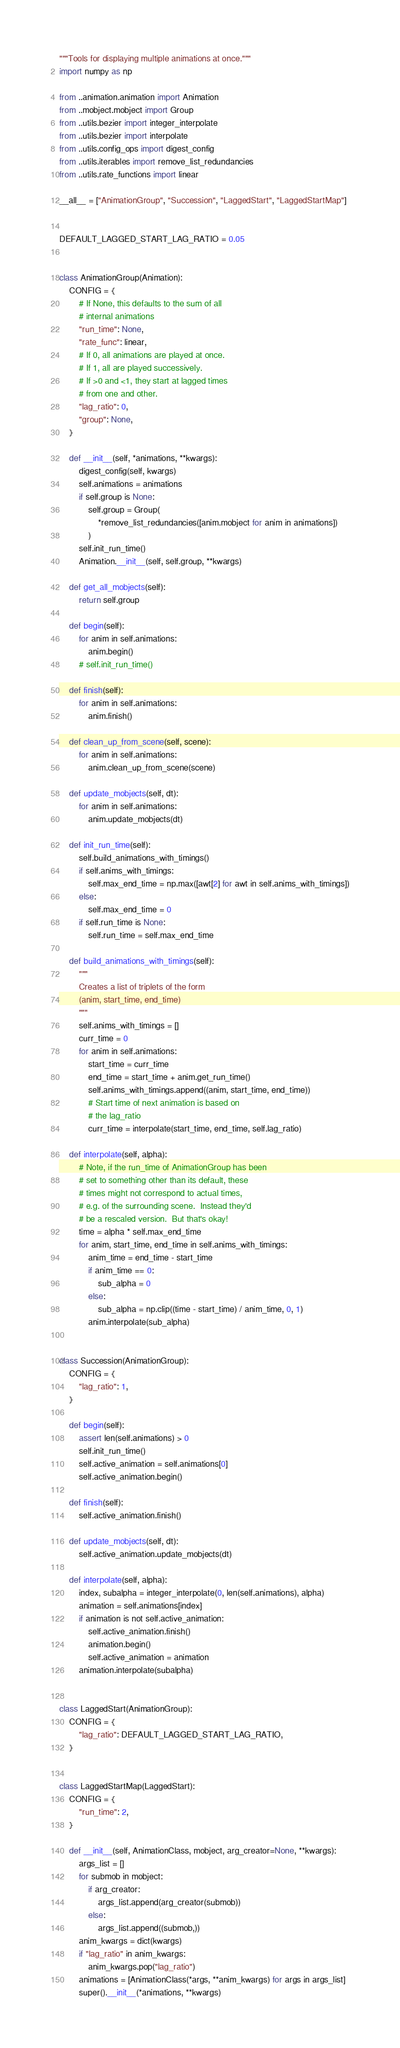Convert code to text. <code><loc_0><loc_0><loc_500><loc_500><_Python_>"""Tools for displaying multiple animations at once."""
import numpy as np

from ..animation.animation import Animation
from ..mobject.mobject import Group
from ..utils.bezier import integer_interpolate
from ..utils.bezier import interpolate
from ..utils.config_ops import digest_config
from ..utils.iterables import remove_list_redundancies
from ..utils.rate_functions import linear

__all__ = ["AnimationGroup", "Succession", "LaggedStart", "LaggedStartMap"]


DEFAULT_LAGGED_START_LAG_RATIO = 0.05


class AnimationGroup(Animation):
    CONFIG = {
        # If None, this defaults to the sum of all
        # internal animations
        "run_time": None,
        "rate_func": linear,
        # If 0, all animations are played at once.
        # If 1, all are played successively.
        # If >0 and <1, they start at lagged times
        # from one and other.
        "lag_ratio": 0,
        "group": None,
    }

    def __init__(self, *animations, **kwargs):
        digest_config(self, kwargs)
        self.animations = animations
        if self.group is None:
            self.group = Group(
                *remove_list_redundancies([anim.mobject for anim in animations])
            )
        self.init_run_time()
        Animation.__init__(self, self.group, **kwargs)

    def get_all_mobjects(self):
        return self.group

    def begin(self):
        for anim in self.animations:
            anim.begin()
        # self.init_run_time()

    def finish(self):
        for anim in self.animations:
            anim.finish()

    def clean_up_from_scene(self, scene):
        for anim in self.animations:
            anim.clean_up_from_scene(scene)

    def update_mobjects(self, dt):
        for anim in self.animations:
            anim.update_mobjects(dt)

    def init_run_time(self):
        self.build_animations_with_timings()
        if self.anims_with_timings:
            self.max_end_time = np.max([awt[2] for awt in self.anims_with_timings])
        else:
            self.max_end_time = 0
        if self.run_time is None:
            self.run_time = self.max_end_time

    def build_animations_with_timings(self):
        """
        Creates a list of triplets of the form
        (anim, start_time, end_time)
        """
        self.anims_with_timings = []
        curr_time = 0
        for anim in self.animations:
            start_time = curr_time
            end_time = start_time + anim.get_run_time()
            self.anims_with_timings.append((anim, start_time, end_time))
            # Start time of next animation is based on
            # the lag_ratio
            curr_time = interpolate(start_time, end_time, self.lag_ratio)

    def interpolate(self, alpha):
        # Note, if the run_time of AnimationGroup has been
        # set to something other than its default, these
        # times might not correspond to actual times,
        # e.g. of the surrounding scene.  Instead they'd
        # be a rescaled version.  But that's okay!
        time = alpha * self.max_end_time
        for anim, start_time, end_time in self.anims_with_timings:
            anim_time = end_time - start_time
            if anim_time == 0:
                sub_alpha = 0
            else:
                sub_alpha = np.clip((time - start_time) / anim_time, 0, 1)
            anim.interpolate(sub_alpha)


class Succession(AnimationGroup):
    CONFIG = {
        "lag_ratio": 1,
    }

    def begin(self):
        assert len(self.animations) > 0
        self.init_run_time()
        self.active_animation = self.animations[0]
        self.active_animation.begin()

    def finish(self):
        self.active_animation.finish()

    def update_mobjects(self, dt):
        self.active_animation.update_mobjects(dt)

    def interpolate(self, alpha):
        index, subalpha = integer_interpolate(0, len(self.animations), alpha)
        animation = self.animations[index]
        if animation is not self.active_animation:
            self.active_animation.finish()
            animation.begin()
            self.active_animation = animation
        animation.interpolate(subalpha)


class LaggedStart(AnimationGroup):
    CONFIG = {
        "lag_ratio": DEFAULT_LAGGED_START_LAG_RATIO,
    }


class LaggedStartMap(LaggedStart):
    CONFIG = {
        "run_time": 2,
    }

    def __init__(self, AnimationClass, mobject, arg_creator=None, **kwargs):
        args_list = []
        for submob in mobject:
            if arg_creator:
                args_list.append(arg_creator(submob))
            else:
                args_list.append((submob,))
        anim_kwargs = dict(kwargs)
        if "lag_ratio" in anim_kwargs:
            anim_kwargs.pop("lag_ratio")
        animations = [AnimationClass(*args, **anim_kwargs) for args in args_list]
        super().__init__(*animations, **kwargs)
</code> 